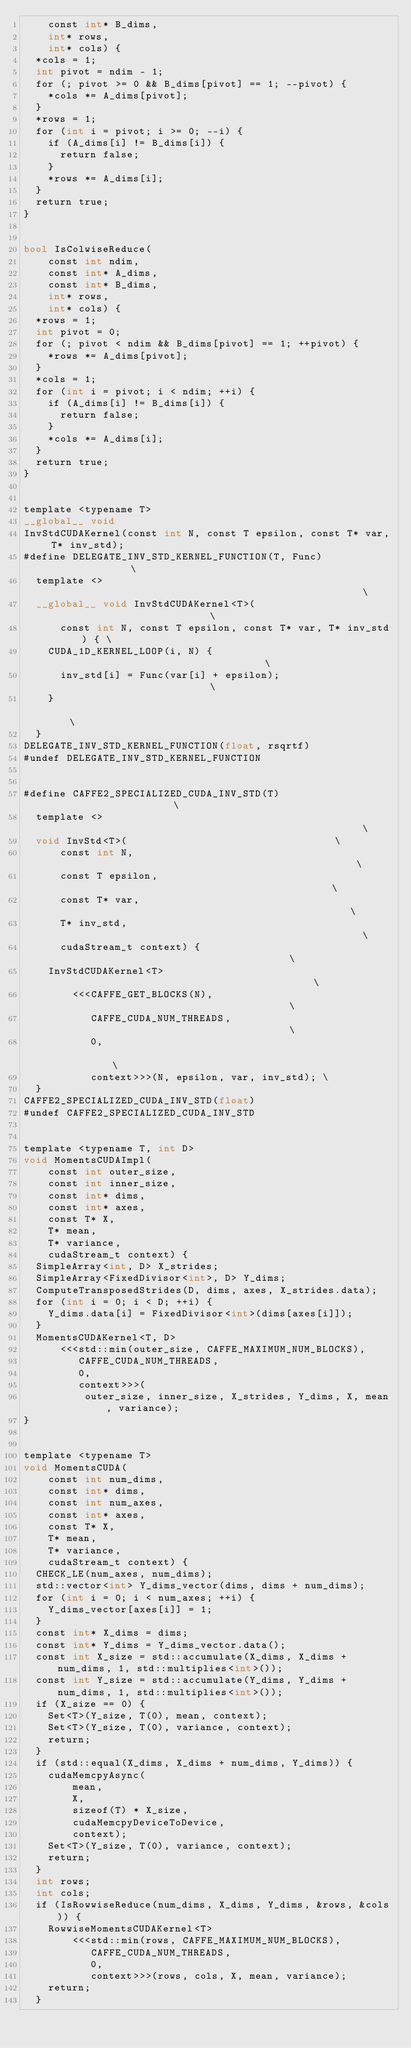<code> <loc_0><loc_0><loc_500><loc_500><_Cuda_>    const int* B_dims,
    int* rows,
    int* cols) {
  *cols = 1;
  int pivot = ndim - 1;
  for (; pivot >= 0 && B_dims[pivot] == 1; --pivot) {
    *cols *= A_dims[pivot];
  }
  *rows = 1;
  for (int i = pivot; i >= 0; --i) {
    if (A_dims[i] != B_dims[i]) {
      return false;
    }
    *rows *= A_dims[i];
  }
  return true;
}


bool IsColwiseReduce(
    const int ndim,
    const int* A_dims,
    const int* B_dims,
    int* rows,
    int* cols) {
  *rows = 1;
  int pivot = 0;
  for (; pivot < ndim && B_dims[pivot] == 1; ++pivot) {
    *rows *= A_dims[pivot];
  }
  *cols = 1;
  for (int i = pivot; i < ndim; ++i) {
    if (A_dims[i] != B_dims[i]) {
      return false;
    }
    *cols *= A_dims[i];
  }
  return true;
}


template <typename T>
__global__ void
InvStdCUDAKernel(const int N, const T epsilon, const T* var, T* inv_std);
#define DELEGATE_INV_STD_KERNEL_FUNCTION(T, Func)               \
  template <>                                                   \
  __global__ void InvStdCUDAKernel<T>(                          \
      const int N, const T epsilon, const T* var, T* inv_std) { \
    CUDA_1D_KERNEL_LOOP(i, N) {                                 \
      inv_std[i] = Func(var[i] + epsilon);                      \
    }                                                           \
  }
DELEGATE_INV_STD_KERNEL_FUNCTION(float, rsqrtf)
#undef DELEGATE_INV_STD_KERNEL_FUNCTION


#define CAFFE2_SPECIALIZED_CUDA_INV_STD(T)                      \
  template <>                                                   \
  void InvStd<T>(                                  \
      const int N,                                              \
      const T epsilon,                                          \
      const T* var,                                             \
      T* inv_std,                                               \
      cudaStream_t context) {                                   \
    InvStdCUDAKernel<T>                                         \
        <<<CAFFE_GET_BLOCKS(N),                                 \
           CAFFE_CUDA_NUM_THREADS,                              \
           0,                                                   \
           context>>>(N, epsilon, var, inv_std); \
  }
CAFFE2_SPECIALIZED_CUDA_INV_STD(float)
#undef CAFFE2_SPECIALIZED_CUDA_INV_STD


template <typename T, int D>
void MomentsCUDAImpl(
    const int outer_size,
    const int inner_size,
    const int* dims,
    const int* axes,
    const T* X,
    T* mean,
    T* variance,
    cudaStream_t context) {
  SimpleArray<int, D> X_strides;
  SimpleArray<FixedDivisor<int>, D> Y_dims;
  ComputeTransposedStrides(D, dims, axes, X_strides.data);
  for (int i = 0; i < D; ++i) {
    Y_dims.data[i] = FixedDivisor<int>(dims[axes[i]]);
  }
  MomentsCUDAKernel<T, D>
      <<<std::min(outer_size, CAFFE_MAXIMUM_NUM_BLOCKS),
         CAFFE_CUDA_NUM_THREADS,
         0,
         context>>>(
          outer_size, inner_size, X_strides, Y_dims, X, mean, variance);
}


template <typename T>
void MomentsCUDA(
    const int num_dims,
    const int* dims,
    const int num_axes,
    const int* axes,
    const T* X,
    T* mean,
    T* variance,
    cudaStream_t context) {
  CHECK_LE(num_axes, num_dims);
  std::vector<int> Y_dims_vector(dims, dims + num_dims);
  for (int i = 0; i < num_axes; ++i) {
    Y_dims_vector[axes[i]] = 1;
  }
  const int* X_dims = dims;
  const int* Y_dims = Y_dims_vector.data();
  const int X_size = std::accumulate(X_dims, X_dims + num_dims, 1, std::multiplies<int>());
  const int Y_size = std::accumulate(Y_dims, Y_dims + num_dims, 1, std::multiplies<int>());
  if (X_size == 0) {
    Set<T>(Y_size, T(0), mean, context);
    Set<T>(Y_size, T(0), variance, context);
    return;
  }
  if (std::equal(X_dims, X_dims + num_dims, Y_dims)) {
    cudaMemcpyAsync(
        mean,
        X,
        sizeof(T) * X_size,
        cudaMemcpyDeviceToDevice,
        context);
    Set<T>(Y_size, T(0), variance, context);
    return;
  }
  int rows;
  int cols;
  if (IsRowwiseReduce(num_dims, X_dims, Y_dims, &rows, &cols)) {
    RowwiseMomentsCUDAKernel<T>
        <<<std::min(rows, CAFFE_MAXIMUM_NUM_BLOCKS),
           CAFFE_CUDA_NUM_THREADS,
           0,
           context>>>(rows, cols, X, mean, variance);
    return;
  }</code> 